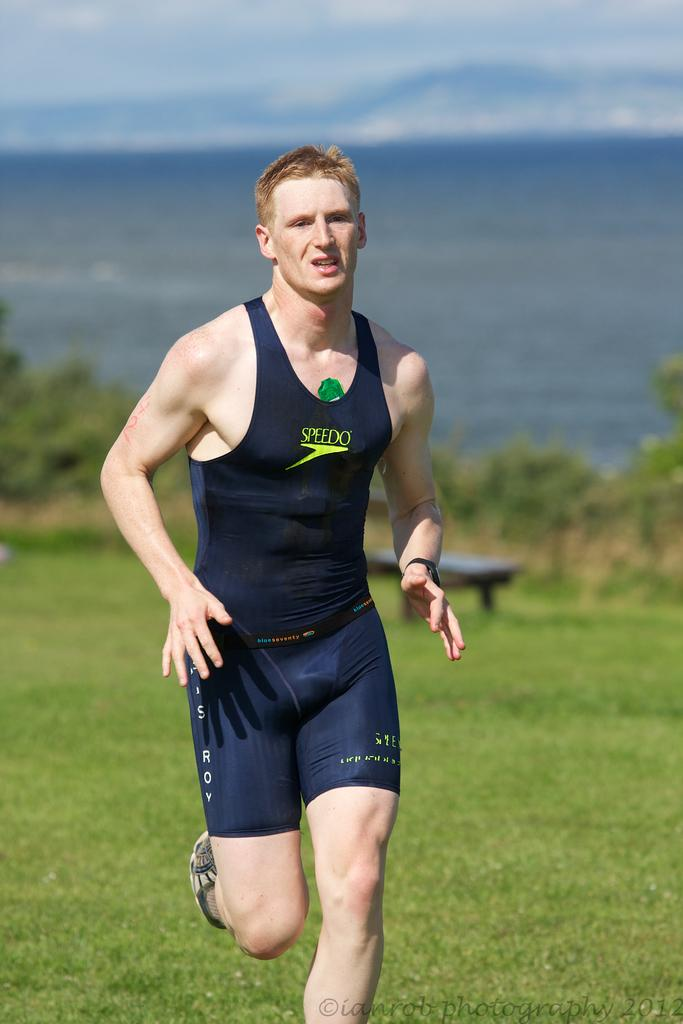What is the main subject of the image? There is a boy in the center of the image. What can be seen in the background of the image? There is greenery in the background of the image. What type of hose is being used by the boy in the image? There is no hose present in the image; the boy is not using any tools or equipment. 